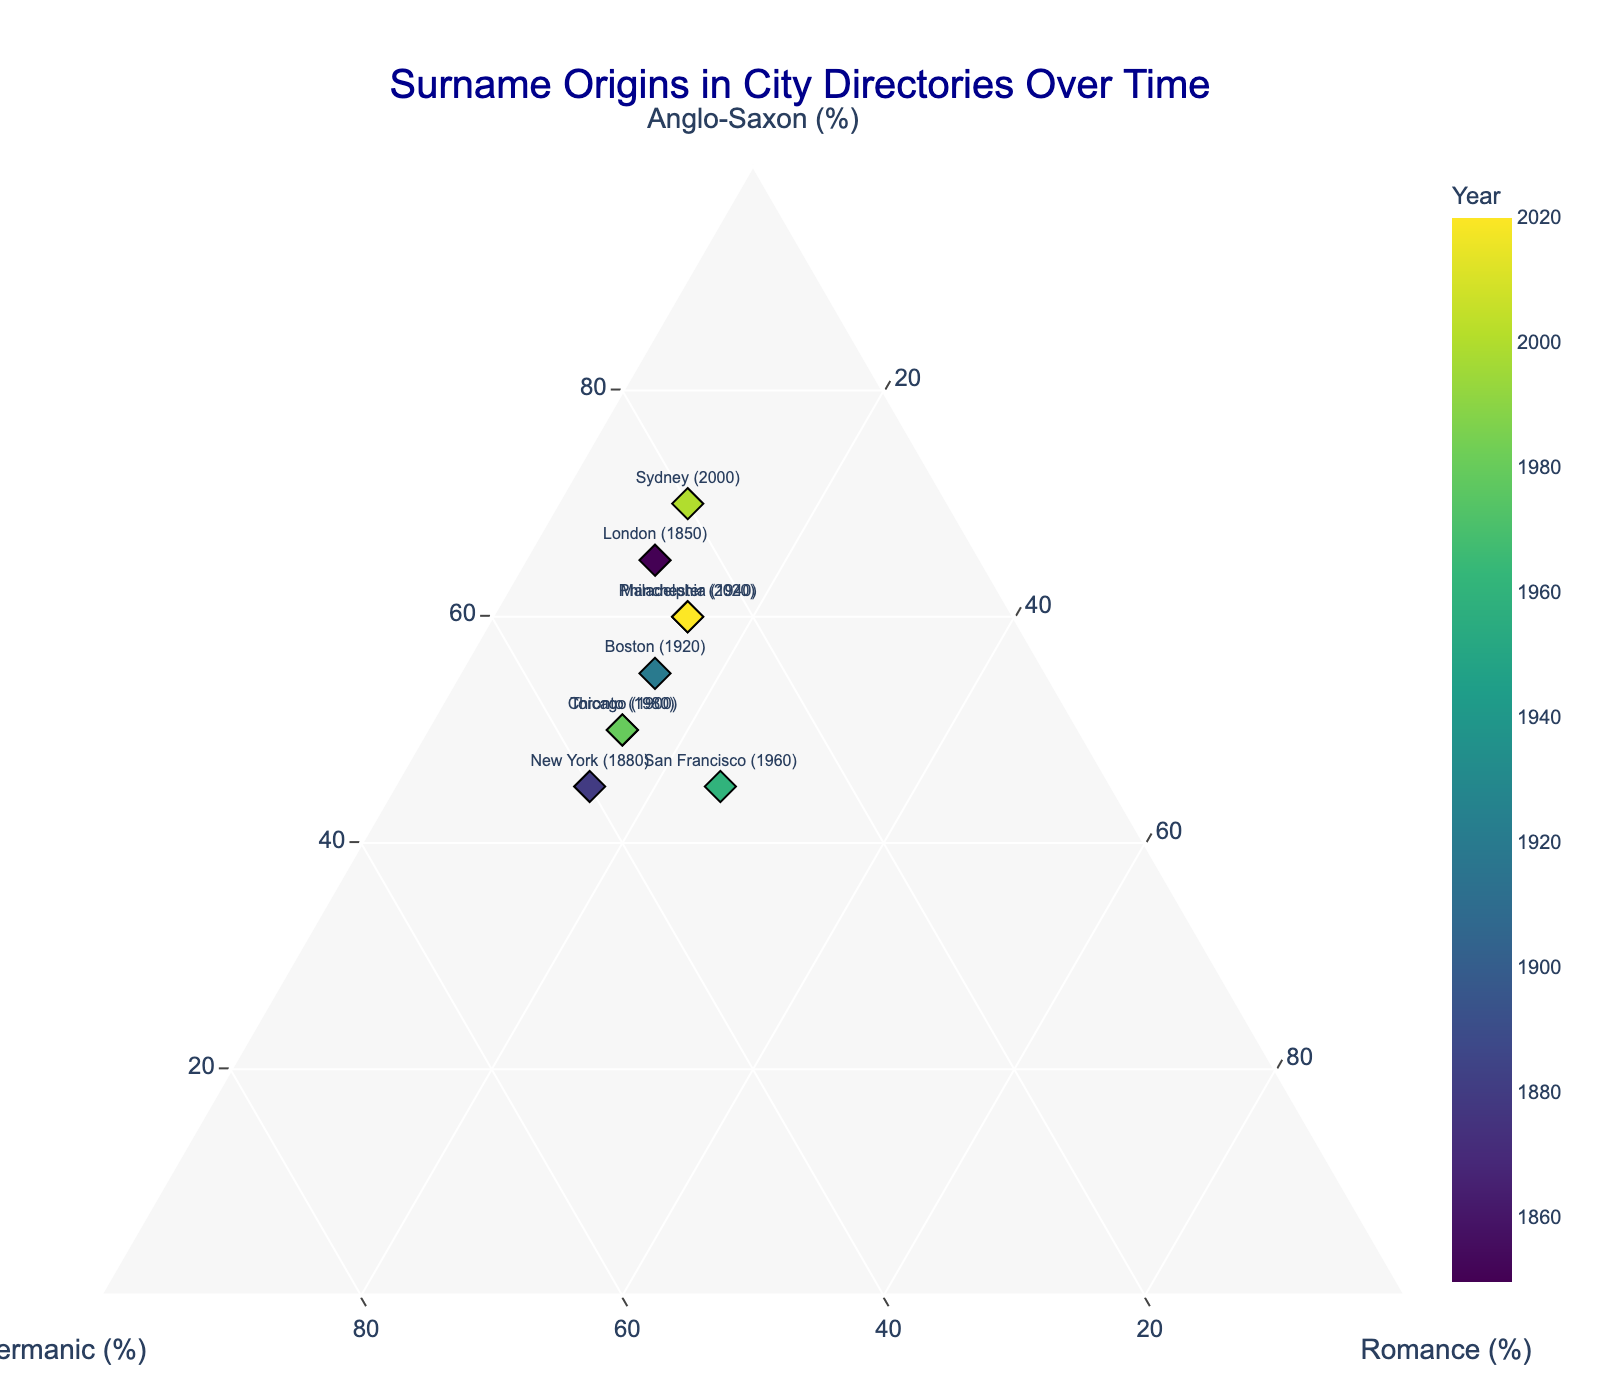Which city has the highest percentage of Anglo-Saxon origin in the most recent year? The dots in the ternary plot label the cities and the years. Looking at the percentage of Anglo-Saxon origin, Sydney in 2000 has the highest at 70%.
Answer: Sydney Which city has the highest percentage of Romance origin? The plot shows percentages of Anglo-Saxon, Germanic, and Romance origins. The highest Romance percentage is in San Francisco in 1960, at 25%.
Answer: San Francisco What is the approximate average percentage of Anglo-Saxon origin for all cities? Adding the Anglo-Saxon percentages: 65 + 45 + 50 + 55 + 60 + 45 + 50 + 70 + 60 = 500. There are 9 cities, so the average is 500/9 ≈ 56.
Answer: 56 In 1880, did New York have a higher percentage of Germanic or Romance origin? Referring to the plot, New York in 1880 has 40% Germanic and 15% Romance origin. Germanic is higher.
Answer: Germanic Which city in the year 1900 is closest to an even distribution of Anglo-Saxon, Germanic, and Romance origins? The plot shows Chicago in 1900 with 50% Anglo-Saxon, 35% Germanic, and 15% Romance, and it's relatively balanced compared to other entries.
Answer: Chicago How has the composition of Anglo-Saxon percentage changed from the earliest to the most recent year? Comparing London in 1850 (65% Anglo-Saxon) to Manchester in 2020 (60% Anglo-Saxon), the percentage has slightly decreased by 5%.
Answer: Decreased by 5% Which city has the most stable percentage of Romance origin over multiple time points? Looking at the different years, cities like Boston (1920) and Philadelphia (1940) maintain a consistent Romance percentage of 15%.
Answer: Philadelphia What's the difference in the percentage of Germanic origin between Toronto (1980) and San Francisco (1960)? Toronto has 35% Germanic, and San Francisco has 30%. The difference is 35% - 30% = 5%.
Answer: 5% How do the coordinates of Sydney (2000) appear in the ternary plot? Sydney in 2000 is plotted with 70% Anglo-Saxon, 20% Germanic, and 10% Romance, indicating the positions on the ternary plot's axes.
Answer: (70, 20, 10) Which city and year exhibit the lowest percentage of Anglo-Saxon origin? Referencing the data points, the lowest Anglo-Saxon percentage is New York in 1880, with 45%.
Answer: New York 